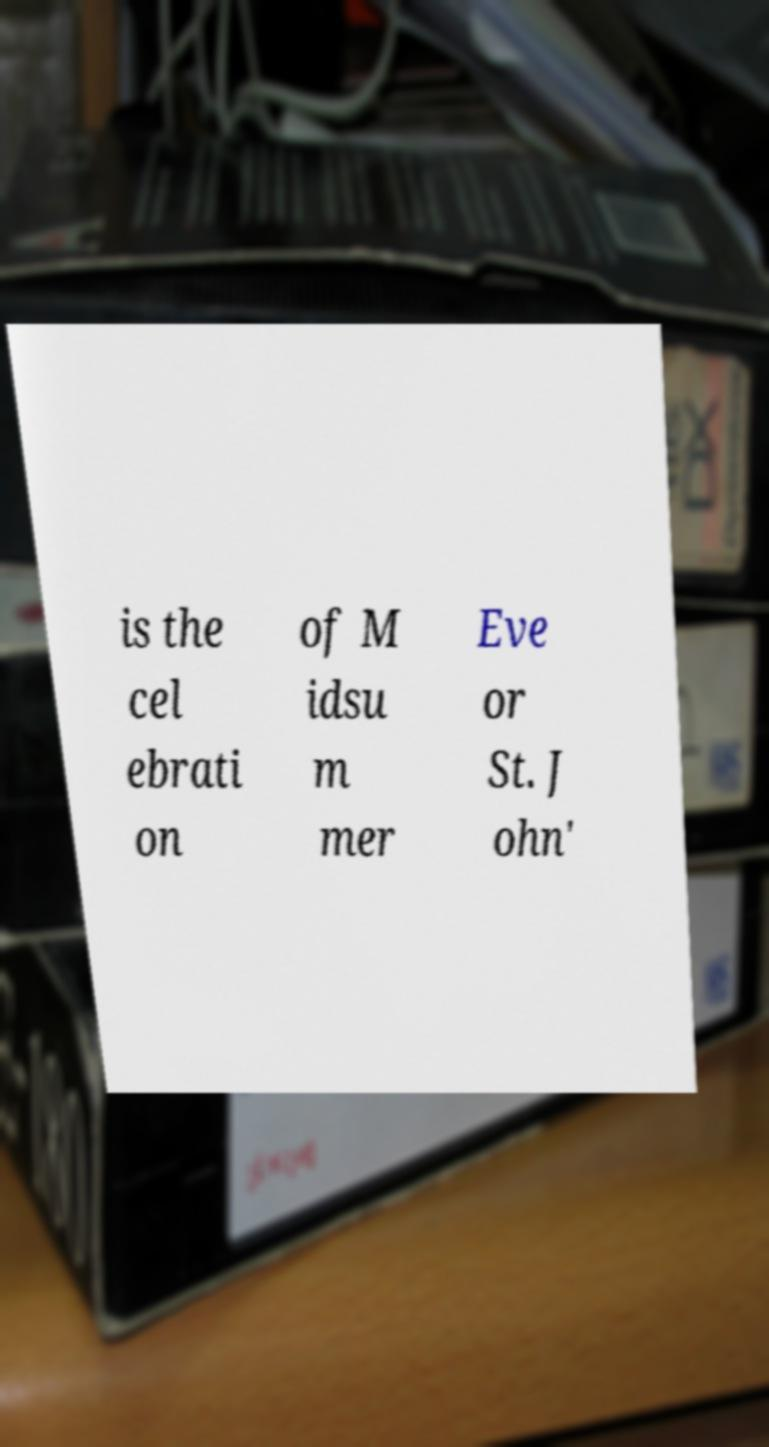Could you extract and type out the text from this image? is the cel ebrati on of M idsu m mer Eve or St. J ohn' 